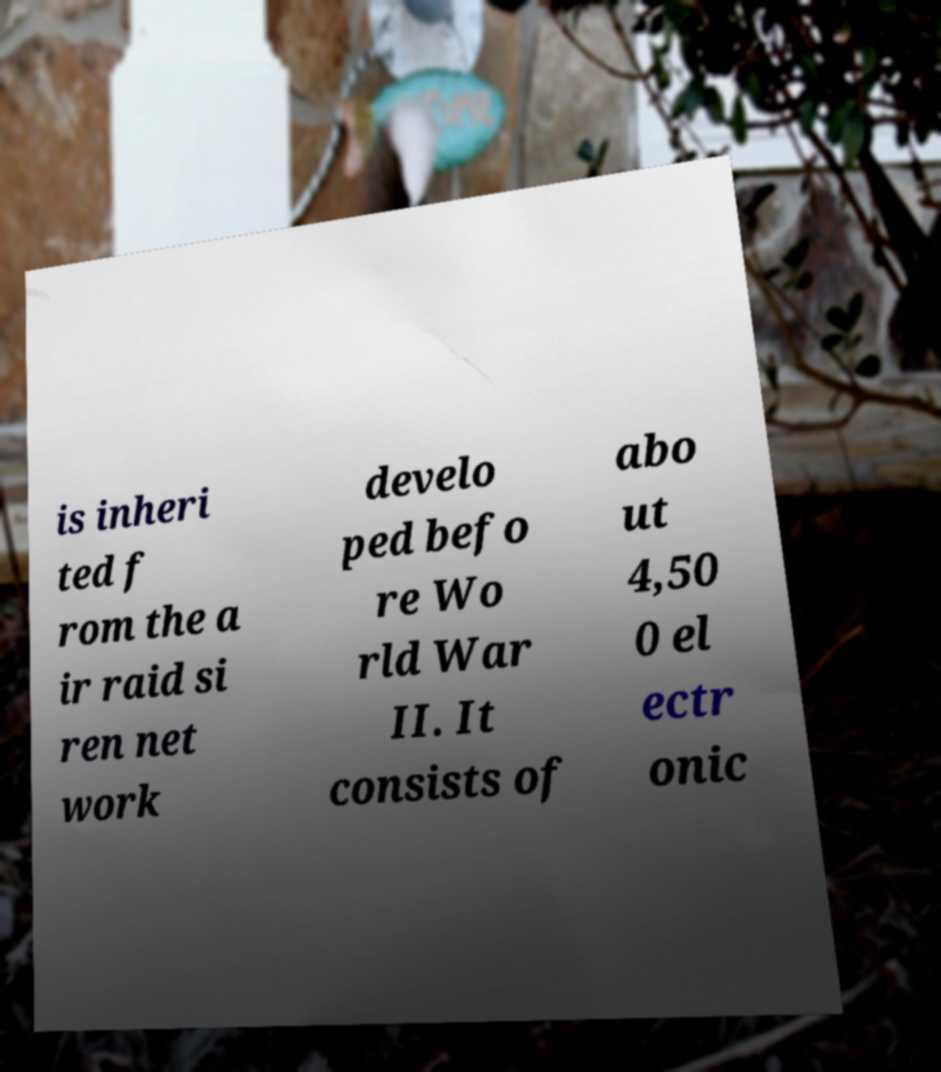Can you accurately transcribe the text from the provided image for me? is inheri ted f rom the a ir raid si ren net work develo ped befo re Wo rld War II. It consists of abo ut 4,50 0 el ectr onic 